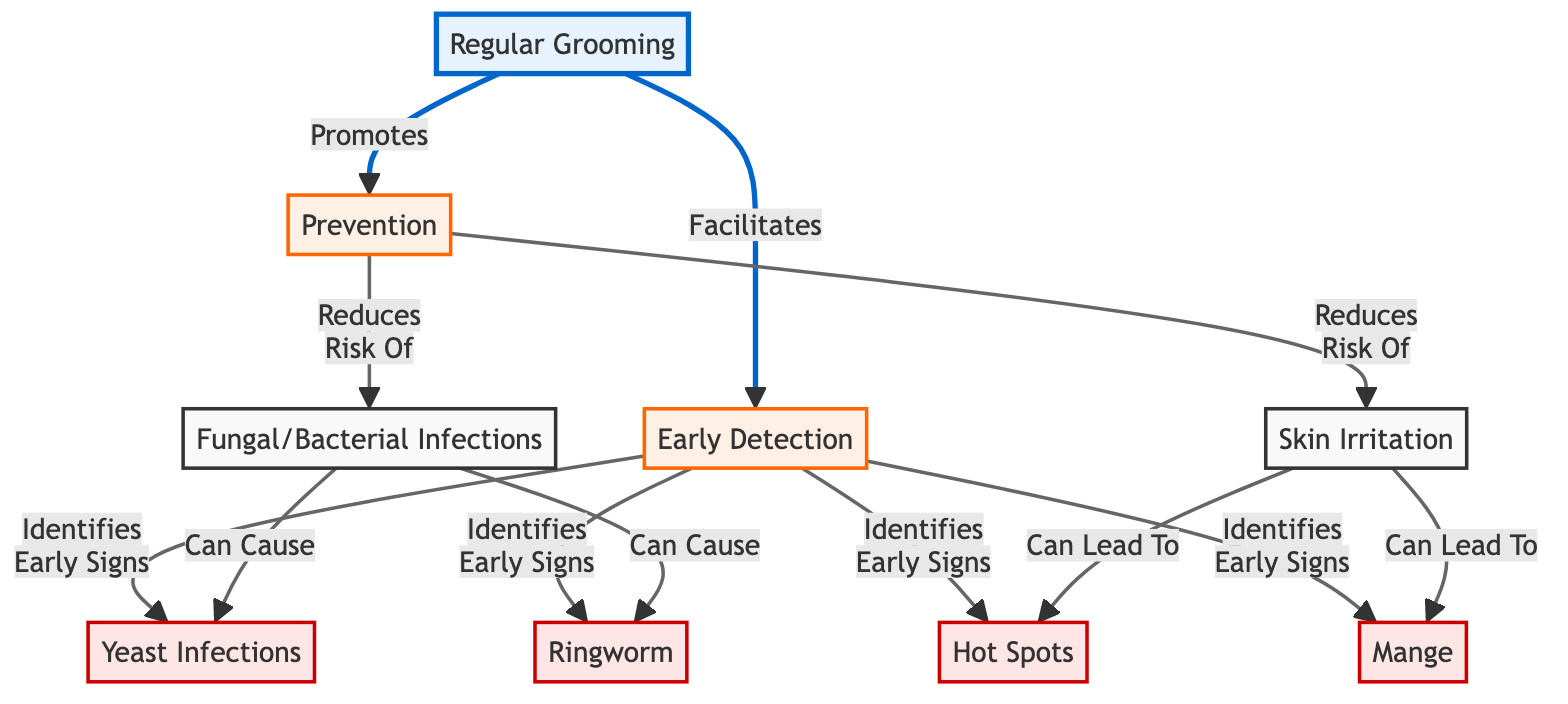What is the first step in the diagram? The diagram starts at the "Regular Grooming" node, which indicates it is the initial step in the process, leading to other nodes.
Answer: Regular Grooming Which disease is identified by early detection in the diagram? The diagram shows multiple connections from "Early Detection," all leading to various diseases including "Yeast Infections," "Ringworm," "Hot Spots," and "Mange."
Answer: Yeast Infections, Ringworm, Hot Spots, Mange How many diseases are linked to early detection? There are four diseases (Yeast Infections, Ringworm, Hot Spots, Mange) connected directly to the "Early Detection" node.
Answer: 4 What does regular grooming promote according to the diagram? The diagram shows that "Regular Grooming" promotes the "Prevention" node, indicating its role in preventing issues.
Answer: Prevention What can skin irritation lead to? The diagram illustrates that "Skin Irritation" can lead to "Hot Spots," "Mange," and it is pivotal in the flow of health issues in dogs.
Answer: Hot Spots, Mange How does prevention affect skin irritation? The diagram indicates that "Prevention" reduces the risk of "Skin Irritation," which is crucial for maintaining dog health.
Answer: Reduces risk What effect do fungal and bacterial infections have on other diseases? The diagram shows that "Fungal/Bacterial Infections" can cause both "Yeast Infections" and "Ringworm," highlighting the interconnectedness of these conditions.
Answer: Can cause How does early detection relate to regular grooming? The flowchart shows that "Regular Grooming" facilitates "Early Detection," emphasizing the importance of grooming for spotting health issues early.
Answer: Facilitates What is the relationship between skin irritation and hot spots? According to the diagram, "Skin Irritation" can lead to "Hot Spots," indicating a direct consequence of irritation.
Answer: Can lead to Hot Spots 